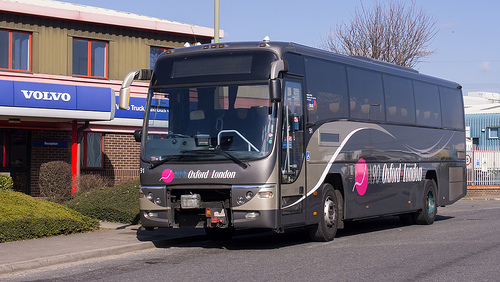Describe the overall setting where the bus is located. The bus is parked outside a commercial building, likely a maintenance or service facility for vehicles, evidenced by signage and other parked buses. What indications suggest that maintenance or servicing might be happening? The presence of maintenance bays, tools seen through open doors, and workers in uniforms suggests active servicing tasks on vehicles. 